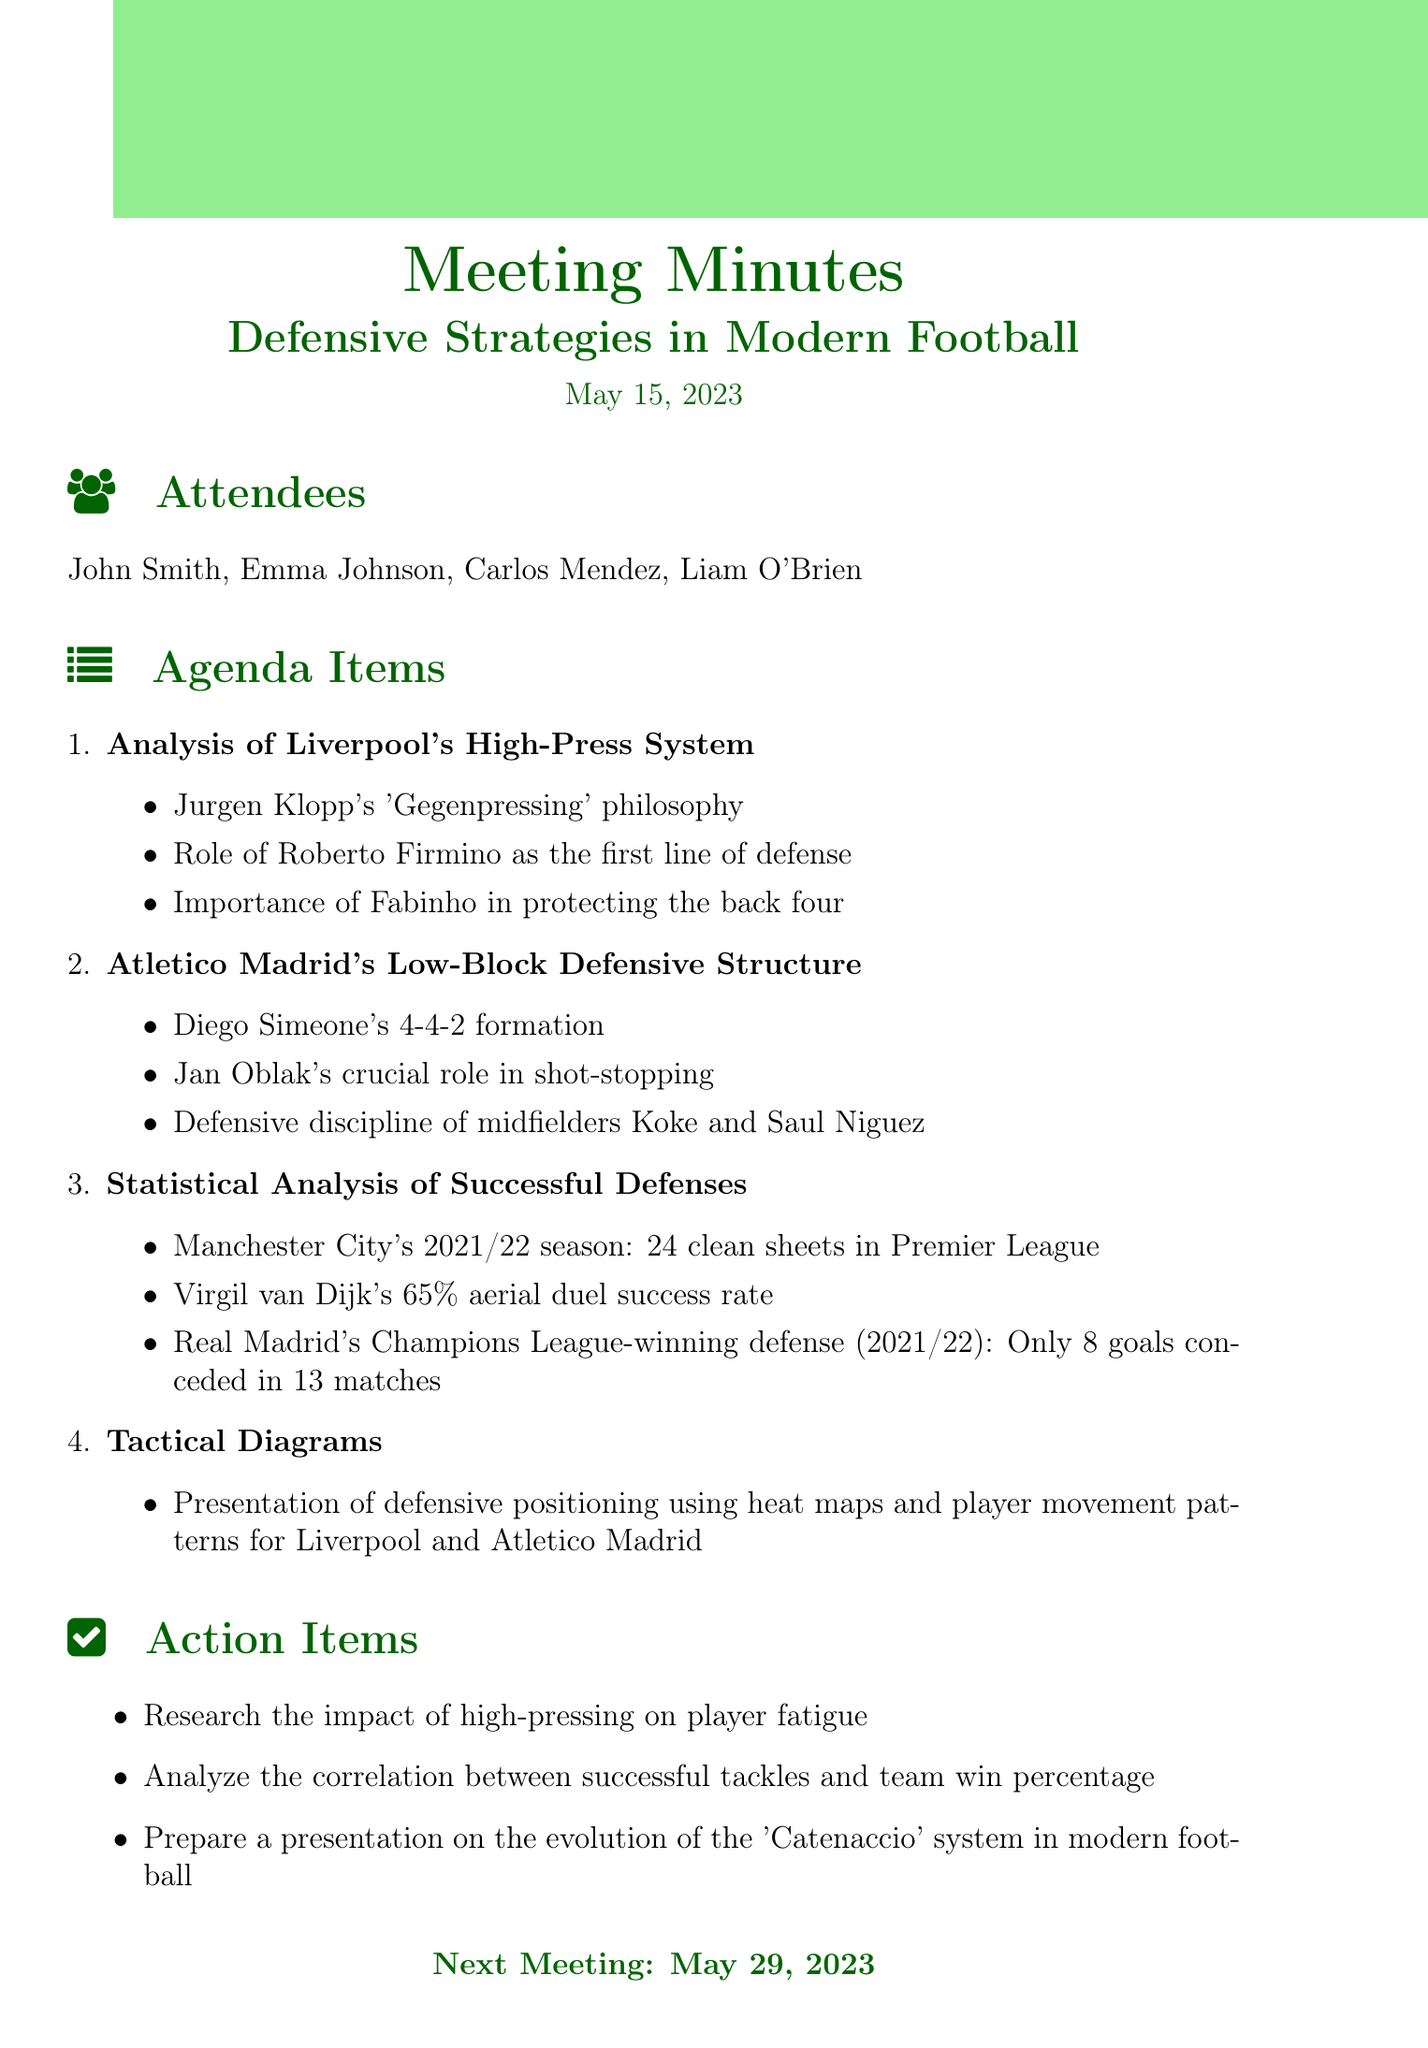What is the date of the meeting? The date of the meeting is explicitly mentioned in the document as May 15, 2023.
Answer: May 15, 2023 Who presented the analysis of Atletico Madrid's defensive structure? The document lists Diego Simeone's formation but does not specify a presenter; however, he is associated with the analysis of Atletico Madrid's structure.
Answer: Diego Simeone How many clean sheets did Manchester City have in the 2021/22 season? The document states that Manchester City achieved 24 clean sheets during the specified season.
Answer: 24 What is Roberto Firmino's role in Liverpool's defense? The document highlights Roberto Firmino's role as the first line of defense in Liverpool's high-press system.
Answer: First line of defense Which team's defensive strategy included only 8 goals conceded in 13 matches? The document notes that Real Madrid's defense conceded only 8 goals in their Champions League-winning campaign during the 2021/22 season.
Answer: Real Madrid What is one of the action items listed in the document? The document lists several action items, one of which is to research high-pressing's impact on player fatigue.
Answer: Research the impact of high-pressing on player fatigue What is the next meeting date? The document specifies that the next meeting is scheduled for May 29, 2023.
Answer: May 29, 2023 